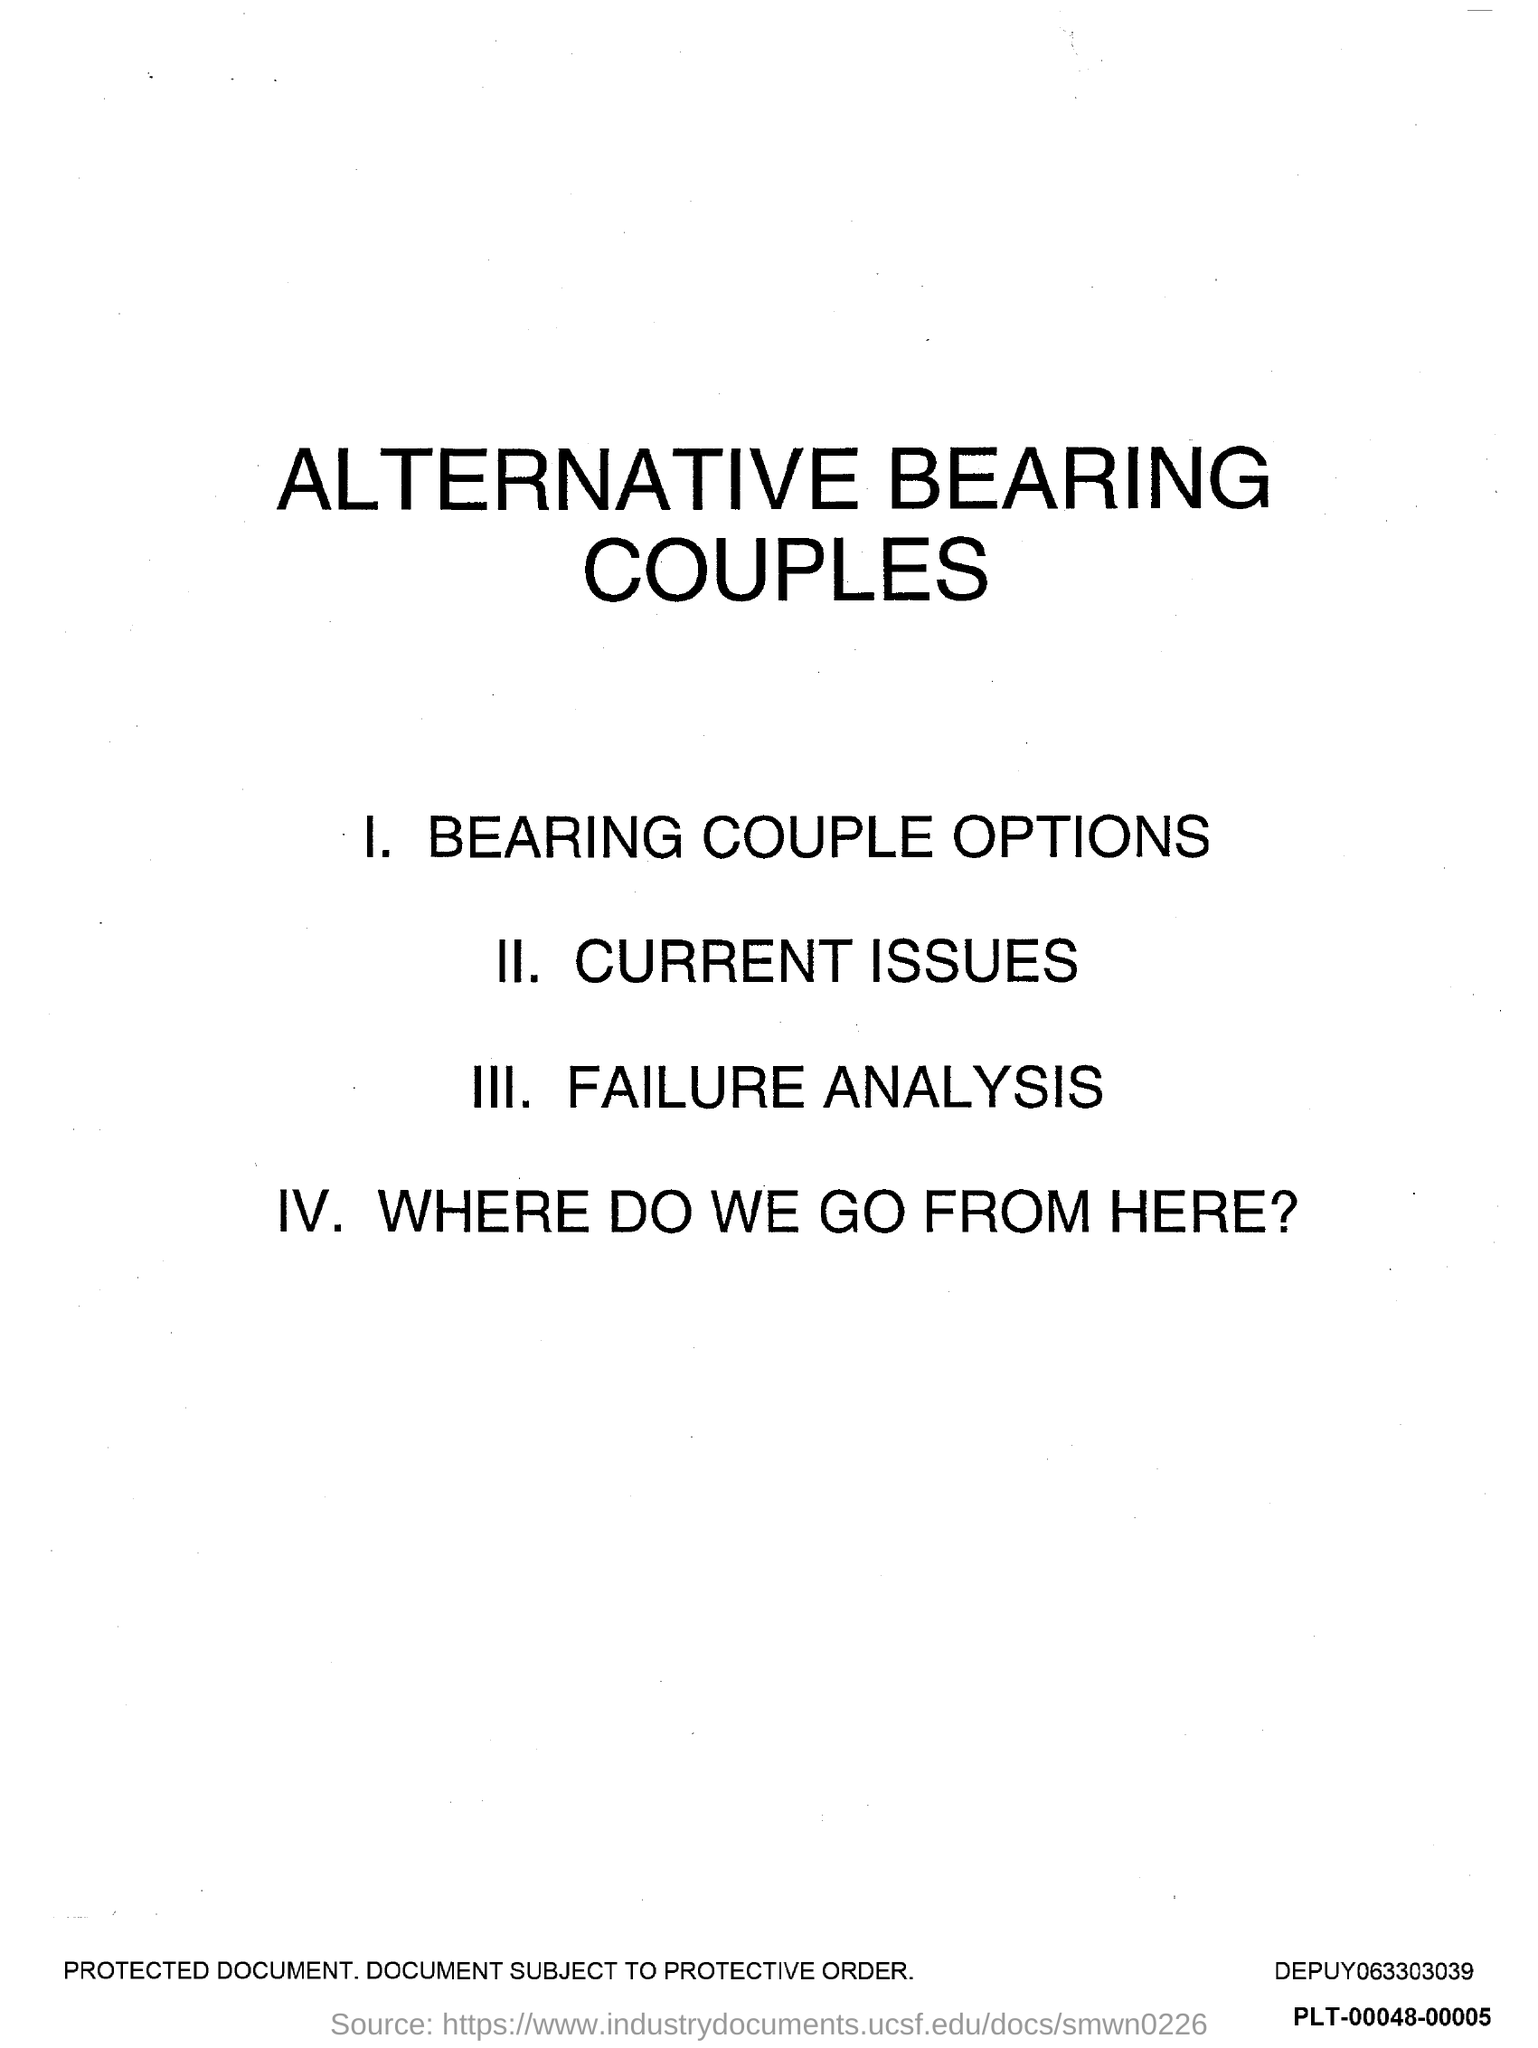What is the title of the document?
Provide a succinct answer. Alternative bearing couples. 